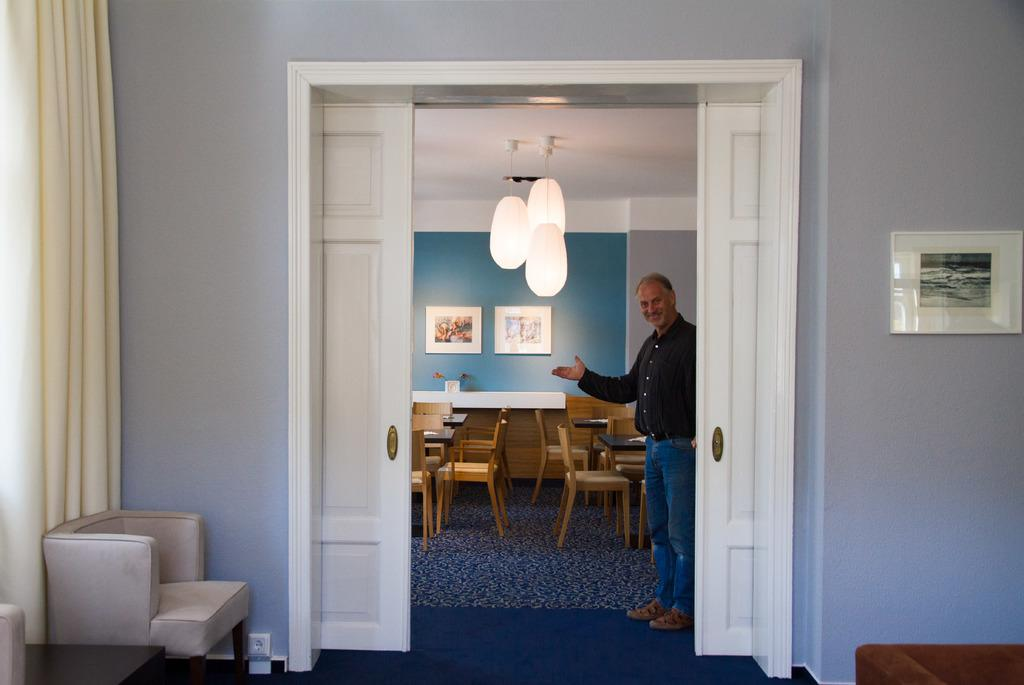What is the person in the image doing? The person is standing and holding a smile. What can be seen in the background of the image? There is a wall in the background, and frames are hanging on the wall. What type of lighting is present in the image? There are lights visible on the top. What type of furniture is in the image? There are tables and chairs in the image. What type of window treatment is present in the image? There is a curtain in the image. What part of the room is visible in the image? The floor is visible in the image. What type of hair is visible on the person in the image? There is no hair visible on the person in the image, as they are holding a smile and not showing their hair. What type of debt is being discussed in the image? There is no mention of debt in the image; it is focused on the person holding a smile and the surrounding environment. 